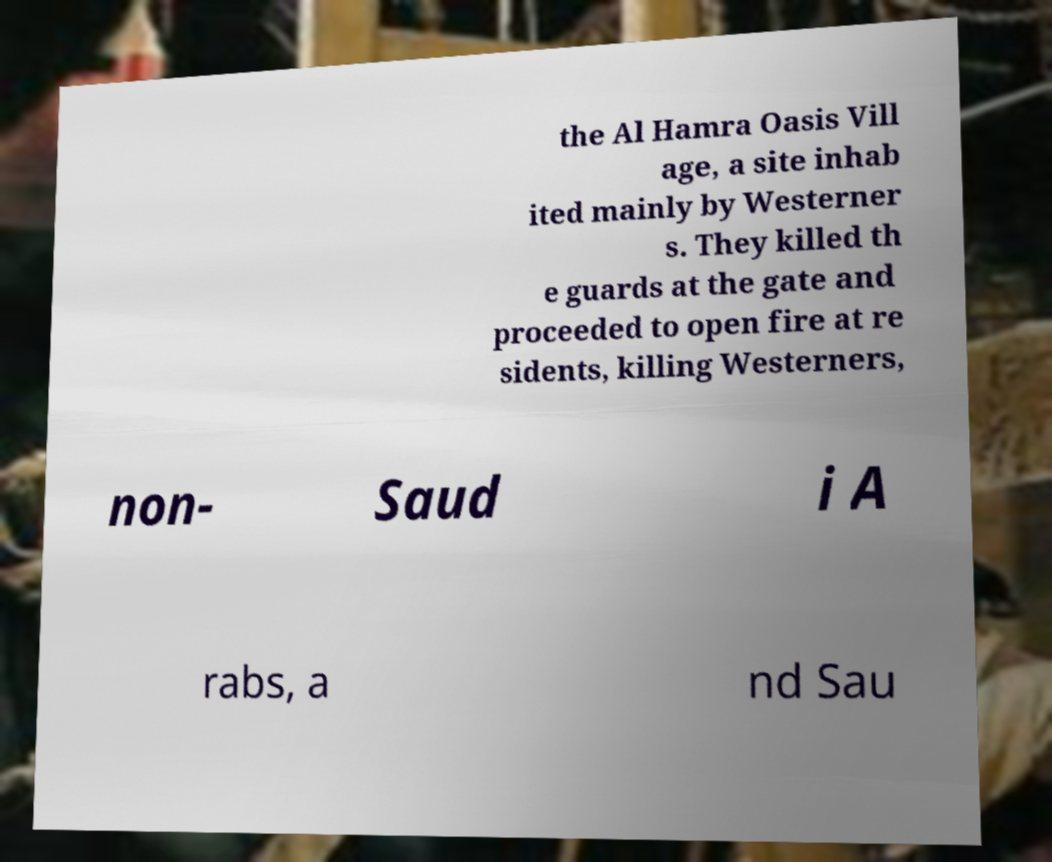Could you extract and type out the text from this image? the Al Hamra Oasis Vill age, a site inhab ited mainly by Westerner s. They killed th e guards at the gate and proceeded to open fire at re sidents, killing Westerners, non- Saud i A rabs, a nd Sau 